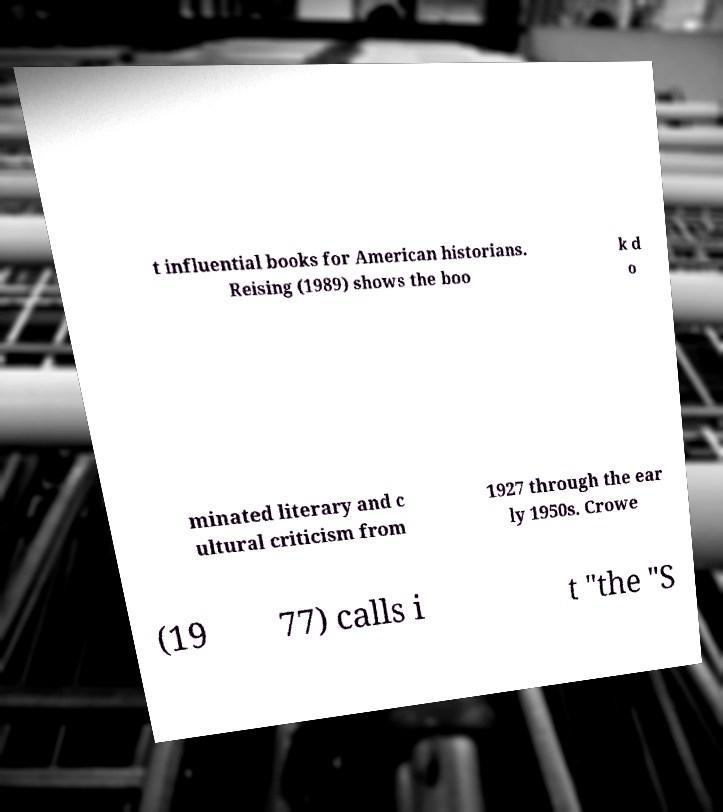Please identify and transcribe the text found in this image. t influential books for American historians. Reising (1989) shows the boo k d o minated literary and c ultural criticism from 1927 through the ear ly 1950s. Crowe (19 77) calls i t "the "S 